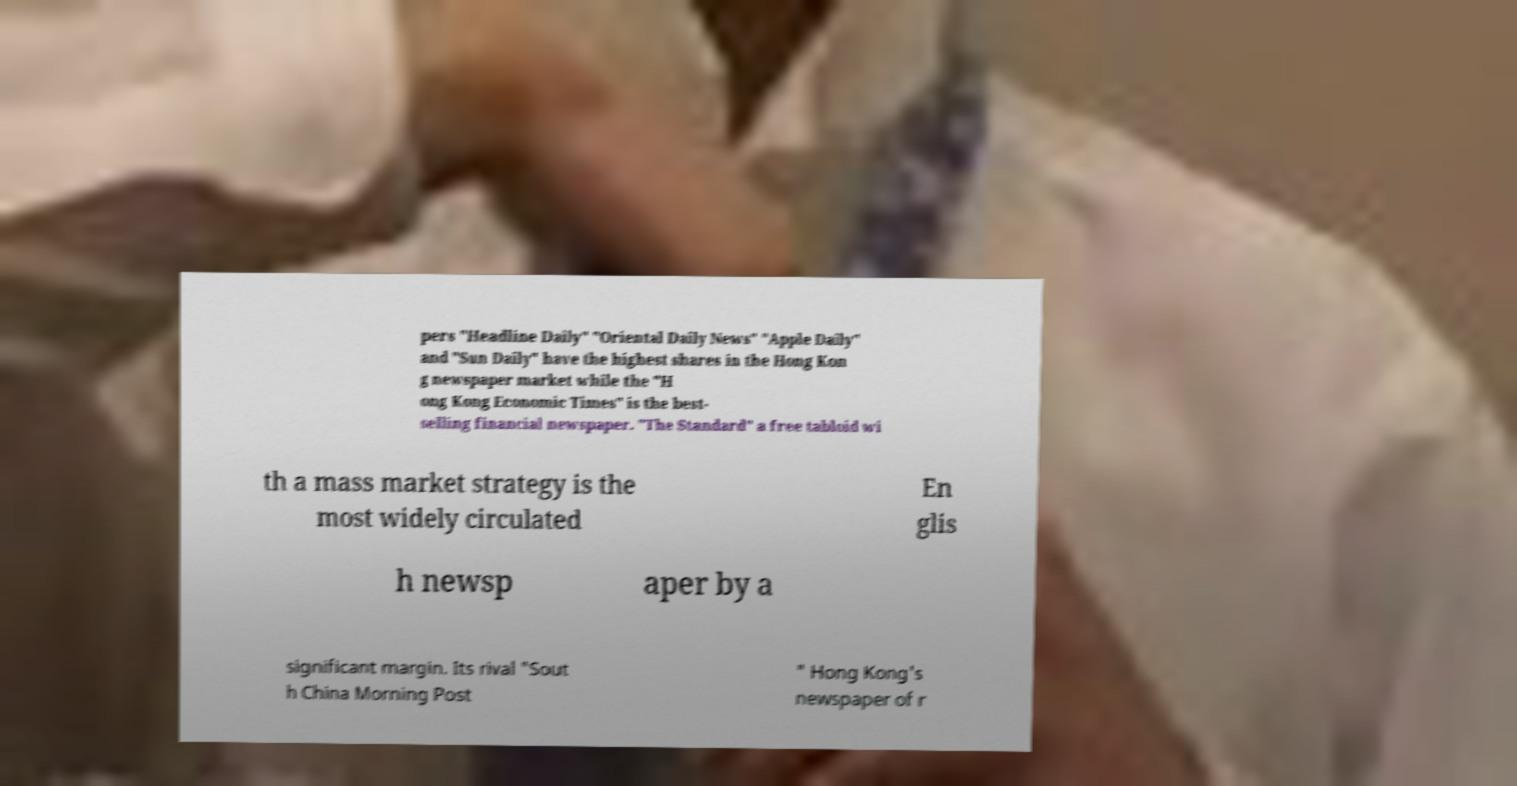Could you extract and type out the text from this image? pers "Headline Daily" "Oriental Daily News" "Apple Daily" and "Sun Daily" have the highest shares in the Hong Kon g newspaper market while the "H ong Kong Economic Times" is the best- selling financial newspaper. "The Standard" a free tabloid wi th a mass market strategy is the most widely circulated En glis h newsp aper by a significant margin. Its rival "Sout h China Morning Post " Hong Kong's newspaper of r 